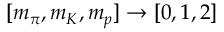Convert formula to latex. <formula><loc_0><loc_0><loc_500><loc_500>[ m _ { \pi } , m _ { K } , m _ { p } ] \rightarrow [ 0 , 1 , 2 ]</formula> 